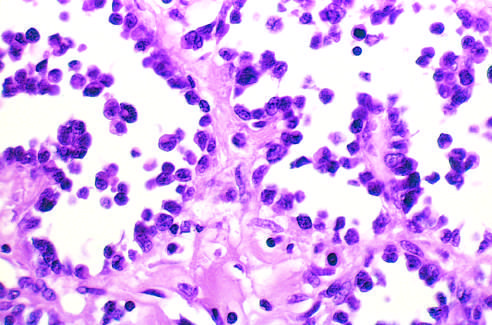re normal marrow cells lined by discohesive, uniform round tumor cells?
Answer the question using a single word or phrase. No 